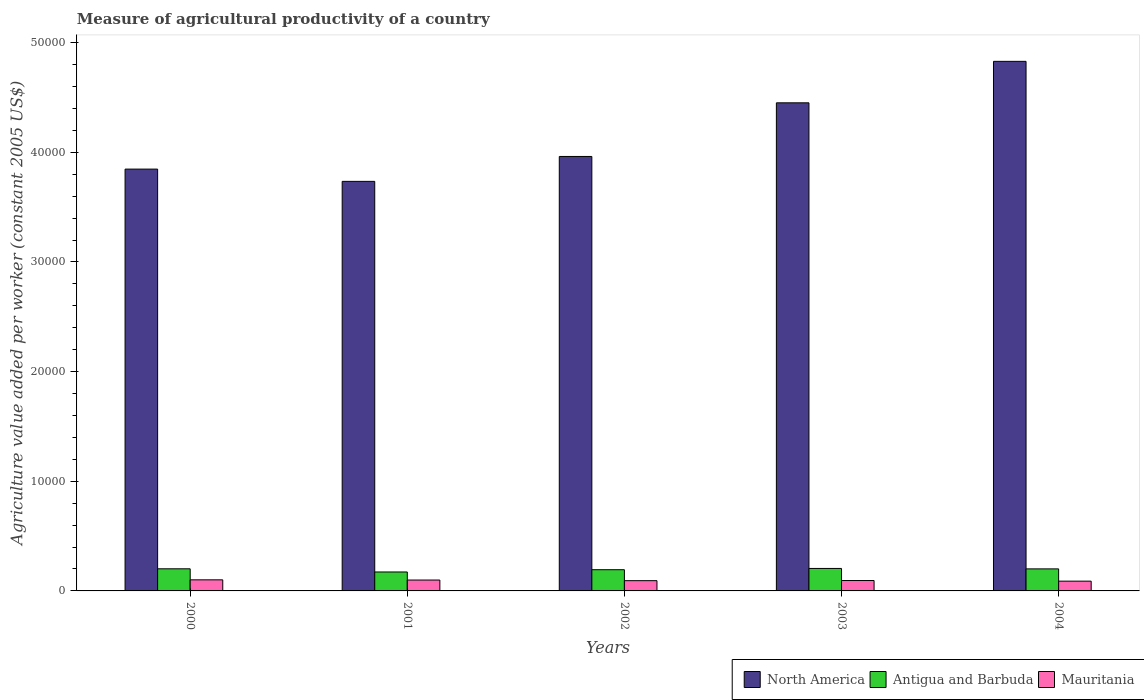How many different coloured bars are there?
Your answer should be very brief. 3. How many groups of bars are there?
Your response must be concise. 5. Are the number of bars on each tick of the X-axis equal?
Give a very brief answer. Yes. What is the label of the 5th group of bars from the left?
Provide a short and direct response. 2004. In how many cases, is the number of bars for a given year not equal to the number of legend labels?
Provide a succinct answer. 0. What is the measure of agricultural productivity in North America in 2000?
Your answer should be very brief. 3.85e+04. Across all years, what is the maximum measure of agricultural productivity in North America?
Your response must be concise. 4.83e+04. Across all years, what is the minimum measure of agricultural productivity in North America?
Your answer should be compact. 3.74e+04. In which year was the measure of agricultural productivity in North America maximum?
Ensure brevity in your answer.  2004. What is the total measure of agricultural productivity in Antigua and Barbuda in the graph?
Your answer should be compact. 9739.5. What is the difference between the measure of agricultural productivity in Antigua and Barbuda in 2003 and that in 2004?
Offer a terse response. 40.12. What is the difference between the measure of agricultural productivity in North America in 2003 and the measure of agricultural productivity in Mauritania in 2004?
Offer a very short reply. 4.36e+04. What is the average measure of agricultural productivity in North America per year?
Your answer should be compact. 4.17e+04. In the year 2000, what is the difference between the measure of agricultural productivity in Antigua and Barbuda and measure of agricultural productivity in Mauritania?
Make the answer very short. 1006.28. What is the ratio of the measure of agricultural productivity in Mauritania in 2001 to that in 2003?
Your response must be concise. 1.05. Is the measure of agricultural productivity in North America in 2000 less than that in 2002?
Provide a succinct answer. Yes. What is the difference between the highest and the second highest measure of agricultural productivity in Mauritania?
Your response must be concise. 18.39. What is the difference between the highest and the lowest measure of agricultural productivity in Mauritania?
Make the answer very short. 119.16. What does the 2nd bar from the left in 2002 represents?
Offer a terse response. Antigua and Barbuda. What does the 3rd bar from the right in 2000 represents?
Your answer should be very brief. North America. Is it the case that in every year, the sum of the measure of agricultural productivity in Antigua and Barbuda and measure of agricultural productivity in Mauritania is greater than the measure of agricultural productivity in North America?
Offer a very short reply. No. How many bars are there?
Offer a very short reply. 15. Are all the bars in the graph horizontal?
Offer a very short reply. No. What is the difference between two consecutive major ticks on the Y-axis?
Offer a terse response. 10000. Are the values on the major ticks of Y-axis written in scientific E-notation?
Provide a succinct answer. No. Does the graph contain any zero values?
Give a very brief answer. No. Does the graph contain grids?
Give a very brief answer. No. How are the legend labels stacked?
Make the answer very short. Horizontal. What is the title of the graph?
Make the answer very short. Measure of agricultural productivity of a country. Does "Gabon" appear as one of the legend labels in the graph?
Provide a short and direct response. No. What is the label or title of the Y-axis?
Ensure brevity in your answer.  Agriculture value added per worker (constant 2005 US$). What is the Agriculture value added per worker (constant 2005 US$) in North America in 2000?
Provide a short and direct response. 3.85e+04. What is the Agriculture value added per worker (constant 2005 US$) of Antigua and Barbuda in 2000?
Provide a succinct answer. 2016.77. What is the Agriculture value added per worker (constant 2005 US$) of Mauritania in 2000?
Ensure brevity in your answer.  1010.49. What is the Agriculture value added per worker (constant 2005 US$) of North America in 2001?
Ensure brevity in your answer.  3.74e+04. What is the Agriculture value added per worker (constant 2005 US$) of Antigua and Barbuda in 2001?
Offer a terse response. 1727.16. What is the Agriculture value added per worker (constant 2005 US$) in Mauritania in 2001?
Your answer should be very brief. 992.1. What is the Agriculture value added per worker (constant 2005 US$) of North America in 2002?
Make the answer very short. 3.96e+04. What is the Agriculture value added per worker (constant 2005 US$) of Antigua and Barbuda in 2002?
Offer a very short reply. 1934.64. What is the Agriculture value added per worker (constant 2005 US$) of Mauritania in 2002?
Your answer should be compact. 936.17. What is the Agriculture value added per worker (constant 2005 US$) of North America in 2003?
Provide a short and direct response. 4.45e+04. What is the Agriculture value added per worker (constant 2005 US$) in Antigua and Barbuda in 2003?
Your answer should be compact. 2050.53. What is the Agriculture value added per worker (constant 2005 US$) in Mauritania in 2003?
Offer a terse response. 947.76. What is the Agriculture value added per worker (constant 2005 US$) of North America in 2004?
Offer a terse response. 4.83e+04. What is the Agriculture value added per worker (constant 2005 US$) of Antigua and Barbuda in 2004?
Give a very brief answer. 2010.41. What is the Agriculture value added per worker (constant 2005 US$) in Mauritania in 2004?
Your response must be concise. 891.32. Across all years, what is the maximum Agriculture value added per worker (constant 2005 US$) of North America?
Provide a short and direct response. 4.83e+04. Across all years, what is the maximum Agriculture value added per worker (constant 2005 US$) of Antigua and Barbuda?
Keep it short and to the point. 2050.53. Across all years, what is the maximum Agriculture value added per worker (constant 2005 US$) in Mauritania?
Your response must be concise. 1010.49. Across all years, what is the minimum Agriculture value added per worker (constant 2005 US$) in North America?
Ensure brevity in your answer.  3.74e+04. Across all years, what is the minimum Agriculture value added per worker (constant 2005 US$) of Antigua and Barbuda?
Offer a terse response. 1727.16. Across all years, what is the minimum Agriculture value added per worker (constant 2005 US$) of Mauritania?
Your answer should be compact. 891.32. What is the total Agriculture value added per worker (constant 2005 US$) in North America in the graph?
Offer a terse response. 2.08e+05. What is the total Agriculture value added per worker (constant 2005 US$) in Antigua and Barbuda in the graph?
Ensure brevity in your answer.  9739.5. What is the total Agriculture value added per worker (constant 2005 US$) in Mauritania in the graph?
Give a very brief answer. 4777.84. What is the difference between the Agriculture value added per worker (constant 2005 US$) of North America in 2000 and that in 2001?
Offer a terse response. 1118.03. What is the difference between the Agriculture value added per worker (constant 2005 US$) in Antigua and Barbuda in 2000 and that in 2001?
Your answer should be very brief. 289.61. What is the difference between the Agriculture value added per worker (constant 2005 US$) in Mauritania in 2000 and that in 2001?
Offer a terse response. 18.39. What is the difference between the Agriculture value added per worker (constant 2005 US$) in North America in 2000 and that in 2002?
Provide a short and direct response. -1152.21. What is the difference between the Agriculture value added per worker (constant 2005 US$) in Antigua and Barbuda in 2000 and that in 2002?
Keep it short and to the point. 82.13. What is the difference between the Agriculture value added per worker (constant 2005 US$) of Mauritania in 2000 and that in 2002?
Provide a succinct answer. 74.31. What is the difference between the Agriculture value added per worker (constant 2005 US$) of North America in 2000 and that in 2003?
Your response must be concise. -6044.44. What is the difference between the Agriculture value added per worker (constant 2005 US$) of Antigua and Barbuda in 2000 and that in 2003?
Your response must be concise. -33.76. What is the difference between the Agriculture value added per worker (constant 2005 US$) in Mauritania in 2000 and that in 2003?
Keep it short and to the point. 62.73. What is the difference between the Agriculture value added per worker (constant 2005 US$) in North America in 2000 and that in 2004?
Offer a terse response. -9826.86. What is the difference between the Agriculture value added per worker (constant 2005 US$) in Antigua and Barbuda in 2000 and that in 2004?
Provide a short and direct response. 6.36. What is the difference between the Agriculture value added per worker (constant 2005 US$) of Mauritania in 2000 and that in 2004?
Keep it short and to the point. 119.16. What is the difference between the Agriculture value added per worker (constant 2005 US$) of North America in 2001 and that in 2002?
Give a very brief answer. -2270.24. What is the difference between the Agriculture value added per worker (constant 2005 US$) of Antigua and Barbuda in 2001 and that in 2002?
Make the answer very short. -207.48. What is the difference between the Agriculture value added per worker (constant 2005 US$) in Mauritania in 2001 and that in 2002?
Your answer should be very brief. 55.93. What is the difference between the Agriculture value added per worker (constant 2005 US$) in North America in 2001 and that in 2003?
Provide a succinct answer. -7162.47. What is the difference between the Agriculture value added per worker (constant 2005 US$) in Antigua and Barbuda in 2001 and that in 2003?
Provide a short and direct response. -323.37. What is the difference between the Agriculture value added per worker (constant 2005 US$) in Mauritania in 2001 and that in 2003?
Provide a succinct answer. 44.34. What is the difference between the Agriculture value added per worker (constant 2005 US$) in North America in 2001 and that in 2004?
Ensure brevity in your answer.  -1.09e+04. What is the difference between the Agriculture value added per worker (constant 2005 US$) in Antigua and Barbuda in 2001 and that in 2004?
Ensure brevity in your answer.  -283.25. What is the difference between the Agriculture value added per worker (constant 2005 US$) of Mauritania in 2001 and that in 2004?
Give a very brief answer. 100.77. What is the difference between the Agriculture value added per worker (constant 2005 US$) of North America in 2002 and that in 2003?
Provide a succinct answer. -4892.23. What is the difference between the Agriculture value added per worker (constant 2005 US$) in Antigua and Barbuda in 2002 and that in 2003?
Give a very brief answer. -115.89. What is the difference between the Agriculture value added per worker (constant 2005 US$) in Mauritania in 2002 and that in 2003?
Give a very brief answer. -11.58. What is the difference between the Agriculture value added per worker (constant 2005 US$) of North America in 2002 and that in 2004?
Your answer should be compact. -8674.65. What is the difference between the Agriculture value added per worker (constant 2005 US$) of Antigua and Barbuda in 2002 and that in 2004?
Keep it short and to the point. -75.77. What is the difference between the Agriculture value added per worker (constant 2005 US$) of Mauritania in 2002 and that in 2004?
Ensure brevity in your answer.  44.85. What is the difference between the Agriculture value added per worker (constant 2005 US$) of North America in 2003 and that in 2004?
Keep it short and to the point. -3782.42. What is the difference between the Agriculture value added per worker (constant 2005 US$) in Antigua and Barbuda in 2003 and that in 2004?
Provide a succinct answer. 40.12. What is the difference between the Agriculture value added per worker (constant 2005 US$) in Mauritania in 2003 and that in 2004?
Ensure brevity in your answer.  56.43. What is the difference between the Agriculture value added per worker (constant 2005 US$) in North America in 2000 and the Agriculture value added per worker (constant 2005 US$) in Antigua and Barbuda in 2001?
Give a very brief answer. 3.67e+04. What is the difference between the Agriculture value added per worker (constant 2005 US$) in North America in 2000 and the Agriculture value added per worker (constant 2005 US$) in Mauritania in 2001?
Ensure brevity in your answer.  3.75e+04. What is the difference between the Agriculture value added per worker (constant 2005 US$) of Antigua and Barbuda in 2000 and the Agriculture value added per worker (constant 2005 US$) of Mauritania in 2001?
Offer a terse response. 1024.67. What is the difference between the Agriculture value added per worker (constant 2005 US$) in North America in 2000 and the Agriculture value added per worker (constant 2005 US$) in Antigua and Barbuda in 2002?
Offer a very short reply. 3.65e+04. What is the difference between the Agriculture value added per worker (constant 2005 US$) in North America in 2000 and the Agriculture value added per worker (constant 2005 US$) in Mauritania in 2002?
Keep it short and to the point. 3.75e+04. What is the difference between the Agriculture value added per worker (constant 2005 US$) in Antigua and Barbuda in 2000 and the Agriculture value added per worker (constant 2005 US$) in Mauritania in 2002?
Keep it short and to the point. 1080.59. What is the difference between the Agriculture value added per worker (constant 2005 US$) of North America in 2000 and the Agriculture value added per worker (constant 2005 US$) of Antigua and Barbuda in 2003?
Ensure brevity in your answer.  3.64e+04. What is the difference between the Agriculture value added per worker (constant 2005 US$) of North America in 2000 and the Agriculture value added per worker (constant 2005 US$) of Mauritania in 2003?
Your response must be concise. 3.75e+04. What is the difference between the Agriculture value added per worker (constant 2005 US$) in Antigua and Barbuda in 2000 and the Agriculture value added per worker (constant 2005 US$) in Mauritania in 2003?
Your answer should be very brief. 1069.01. What is the difference between the Agriculture value added per worker (constant 2005 US$) in North America in 2000 and the Agriculture value added per worker (constant 2005 US$) in Antigua and Barbuda in 2004?
Ensure brevity in your answer.  3.65e+04. What is the difference between the Agriculture value added per worker (constant 2005 US$) in North America in 2000 and the Agriculture value added per worker (constant 2005 US$) in Mauritania in 2004?
Your response must be concise. 3.76e+04. What is the difference between the Agriculture value added per worker (constant 2005 US$) of Antigua and Barbuda in 2000 and the Agriculture value added per worker (constant 2005 US$) of Mauritania in 2004?
Your answer should be very brief. 1125.44. What is the difference between the Agriculture value added per worker (constant 2005 US$) of North America in 2001 and the Agriculture value added per worker (constant 2005 US$) of Antigua and Barbuda in 2002?
Your answer should be very brief. 3.54e+04. What is the difference between the Agriculture value added per worker (constant 2005 US$) of North America in 2001 and the Agriculture value added per worker (constant 2005 US$) of Mauritania in 2002?
Your answer should be very brief. 3.64e+04. What is the difference between the Agriculture value added per worker (constant 2005 US$) in Antigua and Barbuda in 2001 and the Agriculture value added per worker (constant 2005 US$) in Mauritania in 2002?
Your answer should be very brief. 790.99. What is the difference between the Agriculture value added per worker (constant 2005 US$) of North America in 2001 and the Agriculture value added per worker (constant 2005 US$) of Antigua and Barbuda in 2003?
Your response must be concise. 3.53e+04. What is the difference between the Agriculture value added per worker (constant 2005 US$) of North America in 2001 and the Agriculture value added per worker (constant 2005 US$) of Mauritania in 2003?
Offer a terse response. 3.64e+04. What is the difference between the Agriculture value added per worker (constant 2005 US$) in Antigua and Barbuda in 2001 and the Agriculture value added per worker (constant 2005 US$) in Mauritania in 2003?
Offer a very short reply. 779.4. What is the difference between the Agriculture value added per worker (constant 2005 US$) of North America in 2001 and the Agriculture value added per worker (constant 2005 US$) of Antigua and Barbuda in 2004?
Offer a very short reply. 3.53e+04. What is the difference between the Agriculture value added per worker (constant 2005 US$) of North America in 2001 and the Agriculture value added per worker (constant 2005 US$) of Mauritania in 2004?
Give a very brief answer. 3.65e+04. What is the difference between the Agriculture value added per worker (constant 2005 US$) of Antigua and Barbuda in 2001 and the Agriculture value added per worker (constant 2005 US$) of Mauritania in 2004?
Offer a terse response. 835.83. What is the difference between the Agriculture value added per worker (constant 2005 US$) in North America in 2002 and the Agriculture value added per worker (constant 2005 US$) in Antigua and Barbuda in 2003?
Offer a terse response. 3.76e+04. What is the difference between the Agriculture value added per worker (constant 2005 US$) of North America in 2002 and the Agriculture value added per worker (constant 2005 US$) of Mauritania in 2003?
Your answer should be very brief. 3.87e+04. What is the difference between the Agriculture value added per worker (constant 2005 US$) of Antigua and Barbuda in 2002 and the Agriculture value added per worker (constant 2005 US$) of Mauritania in 2003?
Ensure brevity in your answer.  986.88. What is the difference between the Agriculture value added per worker (constant 2005 US$) in North America in 2002 and the Agriculture value added per worker (constant 2005 US$) in Antigua and Barbuda in 2004?
Give a very brief answer. 3.76e+04. What is the difference between the Agriculture value added per worker (constant 2005 US$) of North America in 2002 and the Agriculture value added per worker (constant 2005 US$) of Mauritania in 2004?
Ensure brevity in your answer.  3.87e+04. What is the difference between the Agriculture value added per worker (constant 2005 US$) in Antigua and Barbuda in 2002 and the Agriculture value added per worker (constant 2005 US$) in Mauritania in 2004?
Offer a very short reply. 1043.31. What is the difference between the Agriculture value added per worker (constant 2005 US$) in North America in 2003 and the Agriculture value added per worker (constant 2005 US$) in Antigua and Barbuda in 2004?
Provide a short and direct response. 4.25e+04. What is the difference between the Agriculture value added per worker (constant 2005 US$) of North America in 2003 and the Agriculture value added per worker (constant 2005 US$) of Mauritania in 2004?
Provide a succinct answer. 4.36e+04. What is the difference between the Agriculture value added per worker (constant 2005 US$) of Antigua and Barbuda in 2003 and the Agriculture value added per worker (constant 2005 US$) of Mauritania in 2004?
Keep it short and to the point. 1159.2. What is the average Agriculture value added per worker (constant 2005 US$) of North America per year?
Make the answer very short. 4.17e+04. What is the average Agriculture value added per worker (constant 2005 US$) in Antigua and Barbuda per year?
Make the answer very short. 1947.9. What is the average Agriculture value added per worker (constant 2005 US$) of Mauritania per year?
Make the answer very short. 955.57. In the year 2000, what is the difference between the Agriculture value added per worker (constant 2005 US$) in North America and Agriculture value added per worker (constant 2005 US$) in Antigua and Barbuda?
Your response must be concise. 3.65e+04. In the year 2000, what is the difference between the Agriculture value added per worker (constant 2005 US$) of North America and Agriculture value added per worker (constant 2005 US$) of Mauritania?
Provide a short and direct response. 3.75e+04. In the year 2000, what is the difference between the Agriculture value added per worker (constant 2005 US$) of Antigua and Barbuda and Agriculture value added per worker (constant 2005 US$) of Mauritania?
Your answer should be very brief. 1006.28. In the year 2001, what is the difference between the Agriculture value added per worker (constant 2005 US$) of North America and Agriculture value added per worker (constant 2005 US$) of Antigua and Barbuda?
Your answer should be very brief. 3.56e+04. In the year 2001, what is the difference between the Agriculture value added per worker (constant 2005 US$) in North America and Agriculture value added per worker (constant 2005 US$) in Mauritania?
Ensure brevity in your answer.  3.64e+04. In the year 2001, what is the difference between the Agriculture value added per worker (constant 2005 US$) of Antigua and Barbuda and Agriculture value added per worker (constant 2005 US$) of Mauritania?
Provide a succinct answer. 735.06. In the year 2002, what is the difference between the Agriculture value added per worker (constant 2005 US$) of North America and Agriculture value added per worker (constant 2005 US$) of Antigua and Barbuda?
Your response must be concise. 3.77e+04. In the year 2002, what is the difference between the Agriculture value added per worker (constant 2005 US$) in North America and Agriculture value added per worker (constant 2005 US$) in Mauritania?
Provide a succinct answer. 3.87e+04. In the year 2002, what is the difference between the Agriculture value added per worker (constant 2005 US$) in Antigua and Barbuda and Agriculture value added per worker (constant 2005 US$) in Mauritania?
Keep it short and to the point. 998.47. In the year 2003, what is the difference between the Agriculture value added per worker (constant 2005 US$) of North America and Agriculture value added per worker (constant 2005 US$) of Antigua and Barbuda?
Ensure brevity in your answer.  4.25e+04. In the year 2003, what is the difference between the Agriculture value added per worker (constant 2005 US$) of North America and Agriculture value added per worker (constant 2005 US$) of Mauritania?
Make the answer very short. 4.36e+04. In the year 2003, what is the difference between the Agriculture value added per worker (constant 2005 US$) in Antigua and Barbuda and Agriculture value added per worker (constant 2005 US$) in Mauritania?
Provide a short and direct response. 1102.77. In the year 2004, what is the difference between the Agriculture value added per worker (constant 2005 US$) of North America and Agriculture value added per worker (constant 2005 US$) of Antigua and Barbuda?
Ensure brevity in your answer.  4.63e+04. In the year 2004, what is the difference between the Agriculture value added per worker (constant 2005 US$) in North America and Agriculture value added per worker (constant 2005 US$) in Mauritania?
Your answer should be very brief. 4.74e+04. In the year 2004, what is the difference between the Agriculture value added per worker (constant 2005 US$) of Antigua and Barbuda and Agriculture value added per worker (constant 2005 US$) of Mauritania?
Make the answer very short. 1119.08. What is the ratio of the Agriculture value added per worker (constant 2005 US$) in North America in 2000 to that in 2001?
Your response must be concise. 1.03. What is the ratio of the Agriculture value added per worker (constant 2005 US$) in Antigua and Barbuda in 2000 to that in 2001?
Your response must be concise. 1.17. What is the ratio of the Agriculture value added per worker (constant 2005 US$) of Mauritania in 2000 to that in 2001?
Make the answer very short. 1.02. What is the ratio of the Agriculture value added per worker (constant 2005 US$) in North America in 2000 to that in 2002?
Make the answer very short. 0.97. What is the ratio of the Agriculture value added per worker (constant 2005 US$) in Antigua and Barbuda in 2000 to that in 2002?
Offer a very short reply. 1.04. What is the ratio of the Agriculture value added per worker (constant 2005 US$) of Mauritania in 2000 to that in 2002?
Your answer should be very brief. 1.08. What is the ratio of the Agriculture value added per worker (constant 2005 US$) in North America in 2000 to that in 2003?
Give a very brief answer. 0.86. What is the ratio of the Agriculture value added per worker (constant 2005 US$) of Antigua and Barbuda in 2000 to that in 2003?
Keep it short and to the point. 0.98. What is the ratio of the Agriculture value added per worker (constant 2005 US$) of Mauritania in 2000 to that in 2003?
Provide a succinct answer. 1.07. What is the ratio of the Agriculture value added per worker (constant 2005 US$) of North America in 2000 to that in 2004?
Give a very brief answer. 0.8. What is the ratio of the Agriculture value added per worker (constant 2005 US$) of Antigua and Barbuda in 2000 to that in 2004?
Keep it short and to the point. 1. What is the ratio of the Agriculture value added per worker (constant 2005 US$) in Mauritania in 2000 to that in 2004?
Provide a succinct answer. 1.13. What is the ratio of the Agriculture value added per worker (constant 2005 US$) of North America in 2001 to that in 2002?
Give a very brief answer. 0.94. What is the ratio of the Agriculture value added per worker (constant 2005 US$) in Antigua and Barbuda in 2001 to that in 2002?
Make the answer very short. 0.89. What is the ratio of the Agriculture value added per worker (constant 2005 US$) in Mauritania in 2001 to that in 2002?
Provide a succinct answer. 1.06. What is the ratio of the Agriculture value added per worker (constant 2005 US$) in North America in 2001 to that in 2003?
Your answer should be very brief. 0.84. What is the ratio of the Agriculture value added per worker (constant 2005 US$) in Antigua and Barbuda in 2001 to that in 2003?
Keep it short and to the point. 0.84. What is the ratio of the Agriculture value added per worker (constant 2005 US$) of Mauritania in 2001 to that in 2003?
Provide a short and direct response. 1.05. What is the ratio of the Agriculture value added per worker (constant 2005 US$) in North America in 2001 to that in 2004?
Your answer should be very brief. 0.77. What is the ratio of the Agriculture value added per worker (constant 2005 US$) of Antigua and Barbuda in 2001 to that in 2004?
Make the answer very short. 0.86. What is the ratio of the Agriculture value added per worker (constant 2005 US$) in Mauritania in 2001 to that in 2004?
Your answer should be very brief. 1.11. What is the ratio of the Agriculture value added per worker (constant 2005 US$) of North America in 2002 to that in 2003?
Your response must be concise. 0.89. What is the ratio of the Agriculture value added per worker (constant 2005 US$) in Antigua and Barbuda in 2002 to that in 2003?
Offer a terse response. 0.94. What is the ratio of the Agriculture value added per worker (constant 2005 US$) in North America in 2002 to that in 2004?
Keep it short and to the point. 0.82. What is the ratio of the Agriculture value added per worker (constant 2005 US$) of Antigua and Barbuda in 2002 to that in 2004?
Keep it short and to the point. 0.96. What is the ratio of the Agriculture value added per worker (constant 2005 US$) of Mauritania in 2002 to that in 2004?
Your answer should be very brief. 1.05. What is the ratio of the Agriculture value added per worker (constant 2005 US$) of North America in 2003 to that in 2004?
Your answer should be very brief. 0.92. What is the ratio of the Agriculture value added per worker (constant 2005 US$) in Mauritania in 2003 to that in 2004?
Offer a very short reply. 1.06. What is the difference between the highest and the second highest Agriculture value added per worker (constant 2005 US$) of North America?
Ensure brevity in your answer.  3782.42. What is the difference between the highest and the second highest Agriculture value added per worker (constant 2005 US$) in Antigua and Barbuda?
Your answer should be very brief. 33.76. What is the difference between the highest and the second highest Agriculture value added per worker (constant 2005 US$) in Mauritania?
Ensure brevity in your answer.  18.39. What is the difference between the highest and the lowest Agriculture value added per worker (constant 2005 US$) of North America?
Make the answer very short. 1.09e+04. What is the difference between the highest and the lowest Agriculture value added per worker (constant 2005 US$) of Antigua and Barbuda?
Offer a very short reply. 323.37. What is the difference between the highest and the lowest Agriculture value added per worker (constant 2005 US$) in Mauritania?
Keep it short and to the point. 119.16. 